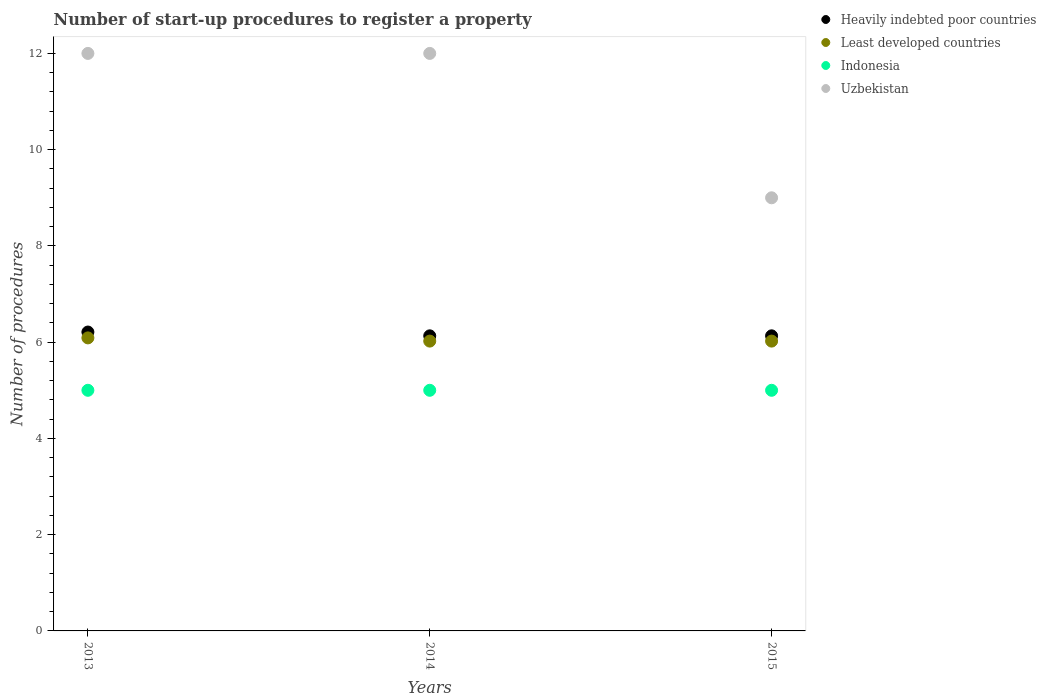Is the number of dotlines equal to the number of legend labels?
Provide a short and direct response. Yes. What is the number of procedures required to register a property in Heavily indebted poor countries in 2014?
Offer a very short reply. 6.13. Across all years, what is the maximum number of procedures required to register a property in Uzbekistan?
Offer a terse response. 12. Across all years, what is the minimum number of procedures required to register a property in Uzbekistan?
Offer a terse response. 9. In which year was the number of procedures required to register a property in Uzbekistan minimum?
Keep it short and to the point. 2015. What is the total number of procedures required to register a property in Uzbekistan in the graph?
Offer a very short reply. 33. What is the difference between the number of procedures required to register a property in Least developed countries in 2013 and that in 2014?
Provide a succinct answer. 0.07. What is the difference between the number of procedures required to register a property in Indonesia in 2015 and the number of procedures required to register a property in Least developed countries in 2014?
Keep it short and to the point. -1.02. What is the average number of procedures required to register a property in Least developed countries per year?
Provide a succinct answer. 6.04. In the year 2015, what is the difference between the number of procedures required to register a property in Indonesia and number of procedures required to register a property in Least developed countries?
Ensure brevity in your answer.  -1.02. What is the ratio of the number of procedures required to register a property in Indonesia in 2013 to that in 2014?
Your response must be concise. 1. Is the difference between the number of procedures required to register a property in Indonesia in 2013 and 2014 greater than the difference between the number of procedures required to register a property in Least developed countries in 2013 and 2014?
Provide a succinct answer. No. What is the difference between the highest and the second highest number of procedures required to register a property in Heavily indebted poor countries?
Offer a terse response. 0.08. What is the difference between the highest and the lowest number of procedures required to register a property in Heavily indebted poor countries?
Your answer should be very brief. 0.08. In how many years, is the number of procedures required to register a property in Indonesia greater than the average number of procedures required to register a property in Indonesia taken over all years?
Your response must be concise. 0. Is it the case that in every year, the sum of the number of procedures required to register a property in Heavily indebted poor countries and number of procedures required to register a property in Least developed countries  is greater than the number of procedures required to register a property in Uzbekistan?
Give a very brief answer. Yes. Does the number of procedures required to register a property in Uzbekistan monotonically increase over the years?
Your answer should be very brief. No. Is the number of procedures required to register a property in Heavily indebted poor countries strictly greater than the number of procedures required to register a property in Indonesia over the years?
Give a very brief answer. Yes. Does the graph contain any zero values?
Your response must be concise. No. How are the legend labels stacked?
Offer a terse response. Vertical. What is the title of the graph?
Offer a terse response. Number of start-up procedures to register a property. What is the label or title of the Y-axis?
Give a very brief answer. Number of procedures. What is the Number of procedures in Heavily indebted poor countries in 2013?
Give a very brief answer. 6.21. What is the Number of procedures of Least developed countries in 2013?
Provide a succinct answer. 6.09. What is the Number of procedures of Indonesia in 2013?
Provide a short and direct response. 5. What is the Number of procedures of Uzbekistan in 2013?
Offer a very short reply. 12. What is the Number of procedures of Heavily indebted poor countries in 2014?
Provide a short and direct response. 6.13. What is the Number of procedures of Least developed countries in 2014?
Keep it short and to the point. 6.02. What is the Number of procedures in Indonesia in 2014?
Your response must be concise. 5. What is the Number of procedures in Uzbekistan in 2014?
Your answer should be very brief. 12. What is the Number of procedures of Heavily indebted poor countries in 2015?
Your answer should be compact. 6.13. What is the Number of procedures in Least developed countries in 2015?
Your response must be concise. 6.02. What is the Number of procedures in Uzbekistan in 2015?
Make the answer very short. 9. Across all years, what is the maximum Number of procedures in Heavily indebted poor countries?
Provide a short and direct response. 6.21. Across all years, what is the maximum Number of procedures in Least developed countries?
Ensure brevity in your answer.  6.09. Across all years, what is the maximum Number of procedures in Indonesia?
Ensure brevity in your answer.  5. Across all years, what is the maximum Number of procedures of Uzbekistan?
Offer a terse response. 12. Across all years, what is the minimum Number of procedures of Heavily indebted poor countries?
Make the answer very short. 6.13. Across all years, what is the minimum Number of procedures in Least developed countries?
Make the answer very short. 6.02. What is the total Number of procedures in Heavily indebted poor countries in the graph?
Ensure brevity in your answer.  18.47. What is the total Number of procedures of Least developed countries in the graph?
Your response must be concise. 18.13. What is the total Number of procedures of Indonesia in the graph?
Provide a succinct answer. 15. What is the total Number of procedures of Uzbekistan in the graph?
Your answer should be compact. 33. What is the difference between the Number of procedures in Heavily indebted poor countries in 2013 and that in 2014?
Make the answer very short. 0.08. What is the difference between the Number of procedures in Least developed countries in 2013 and that in 2014?
Your response must be concise. 0.07. What is the difference between the Number of procedures in Indonesia in 2013 and that in 2014?
Your response must be concise. 0. What is the difference between the Number of procedures of Uzbekistan in 2013 and that in 2014?
Offer a terse response. 0. What is the difference between the Number of procedures in Heavily indebted poor countries in 2013 and that in 2015?
Your response must be concise. 0.08. What is the difference between the Number of procedures of Least developed countries in 2013 and that in 2015?
Make the answer very short. 0.07. What is the difference between the Number of procedures of Least developed countries in 2014 and that in 2015?
Your answer should be very brief. 0. What is the difference between the Number of procedures of Indonesia in 2014 and that in 2015?
Your answer should be very brief. 0. What is the difference between the Number of procedures in Heavily indebted poor countries in 2013 and the Number of procedures in Least developed countries in 2014?
Your response must be concise. 0.19. What is the difference between the Number of procedures of Heavily indebted poor countries in 2013 and the Number of procedures of Indonesia in 2014?
Provide a succinct answer. 1.21. What is the difference between the Number of procedures of Heavily indebted poor countries in 2013 and the Number of procedures of Uzbekistan in 2014?
Your answer should be compact. -5.79. What is the difference between the Number of procedures of Least developed countries in 2013 and the Number of procedures of Indonesia in 2014?
Your answer should be compact. 1.09. What is the difference between the Number of procedures in Least developed countries in 2013 and the Number of procedures in Uzbekistan in 2014?
Keep it short and to the point. -5.91. What is the difference between the Number of procedures of Indonesia in 2013 and the Number of procedures of Uzbekistan in 2014?
Your answer should be very brief. -7. What is the difference between the Number of procedures of Heavily indebted poor countries in 2013 and the Number of procedures of Least developed countries in 2015?
Provide a short and direct response. 0.19. What is the difference between the Number of procedures in Heavily indebted poor countries in 2013 and the Number of procedures in Indonesia in 2015?
Your answer should be very brief. 1.21. What is the difference between the Number of procedures of Heavily indebted poor countries in 2013 and the Number of procedures of Uzbekistan in 2015?
Offer a terse response. -2.79. What is the difference between the Number of procedures in Least developed countries in 2013 and the Number of procedures in Indonesia in 2015?
Keep it short and to the point. 1.09. What is the difference between the Number of procedures of Least developed countries in 2013 and the Number of procedures of Uzbekistan in 2015?
Provide a short and direct response. -2.91. What is the difference between the Number of procedures in Heavily indebted poor countries in 2014 and the Number of procedures in Least developed countries in 2015?
Your answer should be very brief. 0.11. What is the difference between the Number of procedures of Heavily indebted poor countries in 2014 and the Number of procedures of Indonesia in 2015?
Your response must be concise. 1.13. What is the difference between the Number of procedures of Heavily indebted poor countries in 2014 and the Number of procedures of Uzbekistan in 2015?
Ensure brevity in your answer.  -2.87. What is the difference between the Number of procedures of Least developed countries in 2014 and the Number of procedures of Indonesia in 2015?
Offer a terse response. 1.02. What is the difference between the Number of procedures in Least developed countries in 2014 and the Number of procedures in Uzbekistan in 2015?
Your answer should be compact. -2.98. What is the difference between the Number of procedures of Indonesia in 2014 and the Number of procedures of Uzbekistan in 2015?
Your answer should be compact. -4. What is the average Number of procedures in Heavily indebted poor countries per year?
Give a very brief answer. 6.16. What is the average Number of procedures of Least developed countries per year?
Give a very brief answer. 6.04. What is the average Number of procedures of Uzbekistan per year?
Give a very brief answer. 11. In the year 2013, what is the difference between the Number of procedures of Heavily indebted poor countries and Number of procedures of Least developed countries?
Give a very brief answer. 0.12. In the year 2013, what is the difference between the Number of procedures in Heavily indebted poor countries and Number of procedures in Indonesia?
Your answer should be very brief. 1.21. In the year 2013, what is the difference between the Number of procedures in Heavily indebted poor countries and Number of procedures in Uzbekistan?
Offer a terse response. -5.79. In the year 2013, what is the difference between the Number of procedures of Least developed countries and Number of procedures of Indonesia?
Make the answer very short. 1.09. In the year 2013, what is the difference between the Number of procedures in Least developed countries and Number of procedures in Uzbekistan?
Your answer should be compact. -5.91. In the year 2014, what is the difference between the Number of procedures of Heavily indebted poor countries and Number of procedures of Least developed countries?
Your response must be concise. 0.11. In the year 2014, what is the difference between the Number of procedures of Heavily indebted poor countries and Number of procedures of Indonesia?
Provide a short and direct response. 1.13. In the year 2014, what is the difference between the Number of procedures in Heavily indebted poor countries and Number of procedures in Uzbekistan?
Ensure brevity in your answer.  -5.87. In the year 2014, what is the difference between the Number of procedures of Least developed countries and Number of procedures of Indonesia?
Ensure brevity in your answer.  1.02. In the year 2014, what is the difference between the Number of procedures in Least developed countries and Number of procedures in Uzbekistan?
Your answer should be very brief. -5.98. In the year 2014, what is the difference between the Number of procedures of Indonesia and Number of procedures of Uzbekistan?
Offer a terse response. -7. In the year 2015, what is the difference between the Number of procedures in Heavily indebted poor countries and Number of procedures in Least developed countries?
Provide a succinct answer. 0.11. In the year 2015, what is the difference between the Number of procedures in Heavily indebted poor countries and Number of procedures in Indonesia?
Your answer should be very brief. 1.13. In the year 2015, what is the difference between the Number of procedures of Heavily indebted poor countries and Number of procedures of Uzbekistan?
Your answer should be very brief. -2.87. In the year 2015, what is the difference between the Number of procedures of Least developed countries and Number of procedures of Indonesia?
Ensure brevity in your answer.  1.02. In the year 2015, what is the difference between the Number of procedures in Least developed countries and Number of procedures in Uzbekistan?
Provide a succinct answer. -2.98. In the year 2015, what is the difference between the Number of procedures in Indonesia and Number of procedures in Uzbekistan?
Ensure brevity in your answer.  -4. What is the ratio of the Number of procedures of Heavily indebted poor countries in 2013 to that in 2014?
Ensure brevity in your answer.  1.01. What is the ratio of the Number of procedures of Least developed countries in 2013 to that in 2014?
Your response must be concise. 1.01. What is the ratio of the Number of procedures in Indonesia in 2013 to that in 2014?
Make the answer very short. 1. What is the ratio of the Number of procedures of Uzbekistan in 2013 to that in 2014?
Provide a short and direct response. 1. What is the ratio of the Number of procedures in Heavily indebted poor countries in 2013 to that in 2015?
Your response must be concise. 1.01. What is the ratio of the Number of procedures of Least developed countries in 2013 to that in 2015?
Make the answer very short. 1.01. What is the ratio of the Number of procedures in Indonesia in 2013 to that in 2015?
Give a very brief answer. 1. What is the ratio of the Number of procedures in Uzbekistan in 2013 to that in 2015?
Offer a terse response. 1.33. What is the ratio of the Number of procedures of Heavily indebted poor countries in 2014 to that in 2015?
Your response must be concise. 1. What is the ratio of the Number of procedures in Least developed countries in 2014 to that in 2015?
Give a very brief answer. 1. What is the ratio of the Number of procedures in Indonesia in 2014 to that in 2015?
Your answer should be very brief. 1. What is the difference between the highest and the second highest Number of procedures in Heavily indebted poor countries?
Your answer should be compact. 0.08. What is the difference between the highest and the second highest Number of procedures in Least developed countries?
Your response must be concise. 0.07. What is the difference between the highest and the second highest Number of procedures of Uzbekistan?
Give a very brief answer. 0. What is the difference between the highest and the lowest Number of procedures of Heavily indebted poor countries?
Provide a succinct answer. 0.08. What is the difference between the highest and the lowest Number of procedures of Least developed countries?
Offer a very short reply. 0.07. What is the difference between the highest and the lowest Number of procedures in Indonesia?
Your response must be concise. 0. 